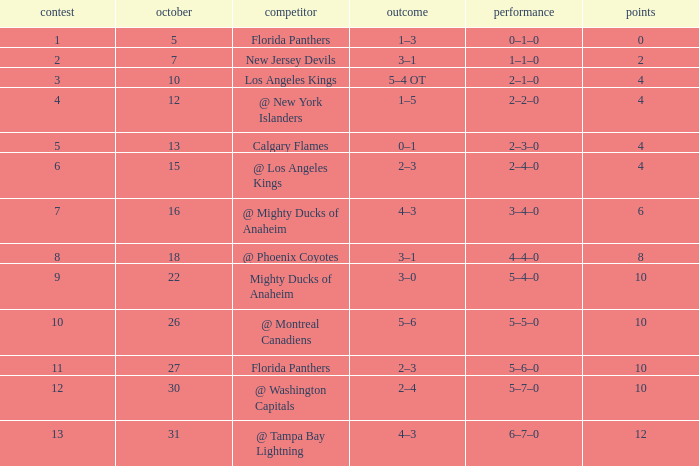What team has a score of 2 3–1. 